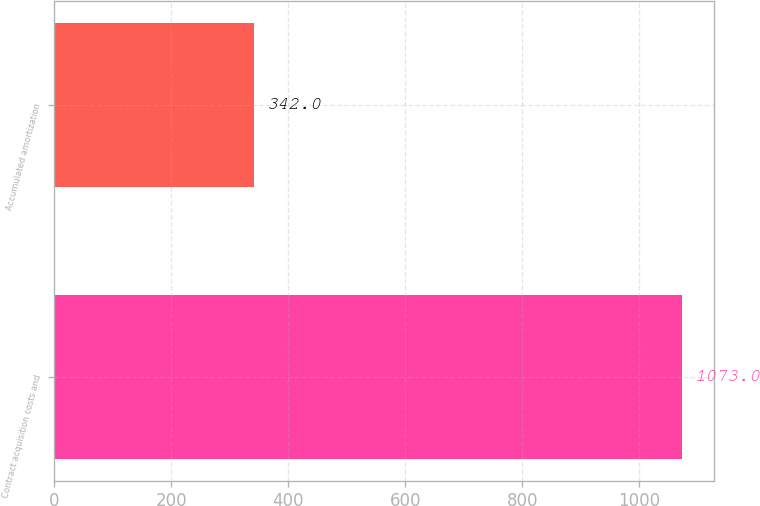Convert chart. <chart><loc_0><loc_0><loc_500><loc_500><bar_chart><fcel>Contract acquisition costs and<fcel>Accumulated amortization<nl><fcel>1073<fcel>342<nl></chart> 